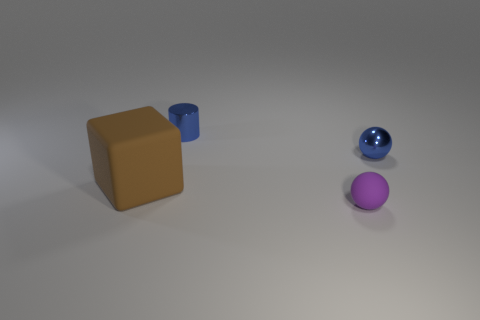What are the colors of the objects in the image? The objects displayed have distinct colors. There is a brown cube, a blue cylinder, and two spheres, one of a shimmering blue and the other of a soft purple hue. How are the objects arranged in the space? The objects are spaced apart on a flat surface. The brown cube is to the left, the blue cylinder is in the middle, and the spheres are towards the right, with a hint of depth as if they could be arranged by size or order. 